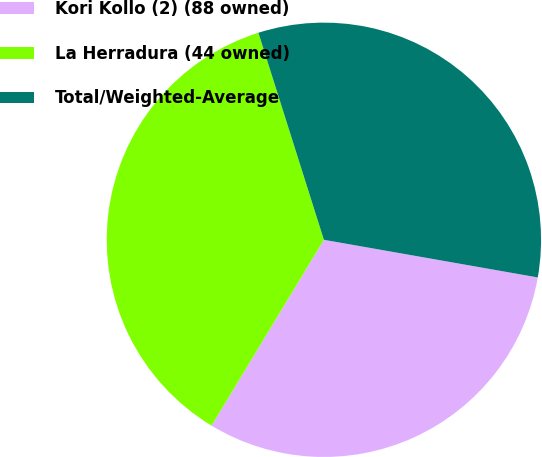Convert chart to OTSL. <chart><loc_0><loc_0><loc_500><loc_500><pie_chart><fcel>Kori Kollo (2) (88 owned)<fcel>La Herradura (44 owned)<fcel>Total/Weighted-Average<nl><fcel>30.88%<fcel>36.47%<fcel>32.65%<nl></chart> 